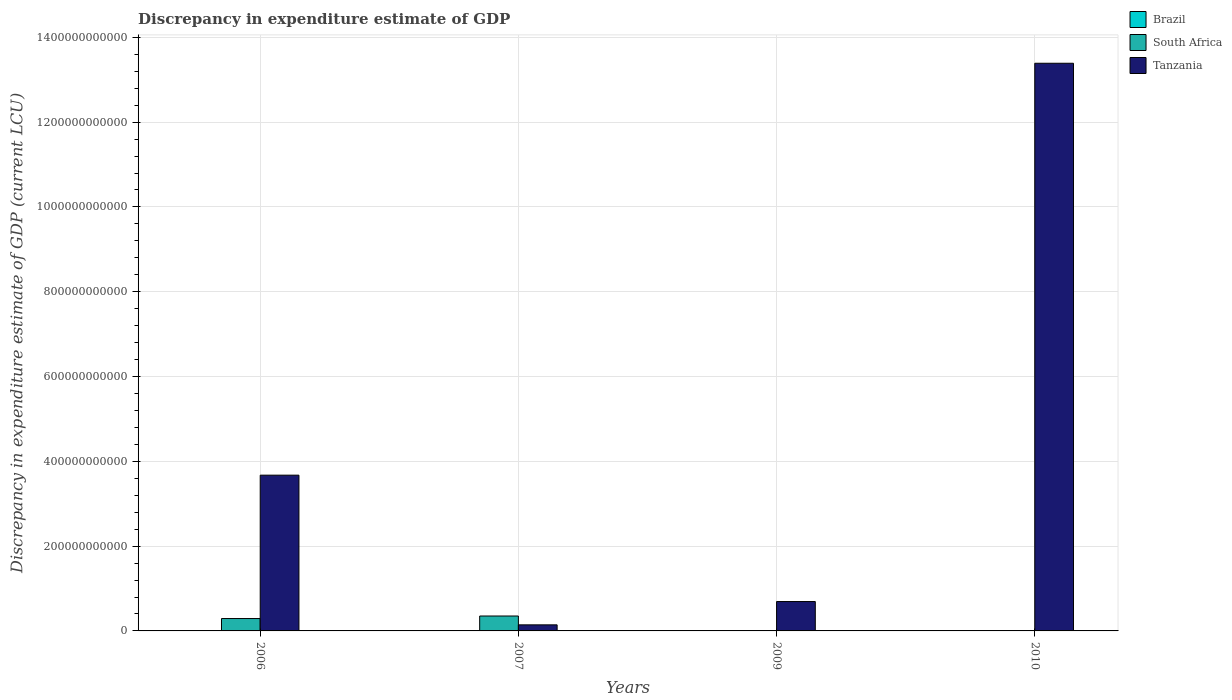Are the number of bars per tick equal to the number of legend labels?
Your response must be concise. No. In how many cases, is the number of bars for a given year not equal to the number of legend labels?
Your answer should be very brief. 4. What is the discrepancy in expenditure estimate of GDP in Brazil in 2009?
Offer a very short reply. 1.00e+06. Across all years, what is the maximum discrepancy in expenditure estimate of GDP in South Africa?
Make the answer very short. 3.52e+1. Across all years, what is the minimum discrepancy in expenditure estimate of GDP in Brazil?
Provide a short and direct response. 0. In which year was the discrepancy in expenditure estimate of GDP in South Africa maximum?
Ensure brevity in your answer.  2007. What is the total discrepancy in expenditure estimate of GDP in Tanzania in the graph?
Give a very brief answer. 1.79e+12. What is the difference between the discrepancy in expenditure estimate of GDP in Brazil in 2009 and that in 2010?
Provide a short and direct response. -0. What is the difference between the discrepancy in expenditure estimate of GDP in Tanzania in 2007 and the discrepancy in expenditure estimate of GDP in South Africa in 2010?
Keep it short and to the point. 1.43e+1. What is the average discrepancy in expenditure estimate of GDP in Brazil per year?
Make the answer very short. 5.00e+05. In the year 2006, what is the difference between the discrepancy in expenditure estimate of GDP in South Africa and discrepancy in expenditure estimate of GDP in Tanzania?
Your answer should be compact. -3.38e+11. What is the ratio of the discrepancy in expenditure estimate of GDP in Tanzania in 2006 to that in 2009?
Give a very brief answer. 5.3. What is the difference between the highest and the lowest discrepancy in expenditure estimate of GDP in South Africa?
Provide a succinct answer. 3.52e+1. Are all the bars in the graph horizontal?
Keep it short and to the point. No. What is the difference between two consecutive major ticks on the Y-axis?
Keep it short and to the point. 2.00e+11. Are the values on the major ticks of Y-axis written in scientific E-notation?
Give a very brief answer. No. Does the graph contain any zero values?
Give a very brief answer. Yes. Does the graph contain grids?
Offer a terse response. Yes. Where does the legend appear in the graph?
Offer a very short reply. Top right. How are the legend labels stacked?
Your answer should be compact. Vertical. What is the title of the graph?
Your response must be concise. Discrepancy in expenditure estimate of GDP. Does "Malaysia" appear as one of the legend labels in the graph?
Offer a terse response. No. What is the label or title of the Y-axis?
Your response must be concise. Discrepancy in expenditure estimate of GDP (current LCU). What is the Discrepancy in expenditure estimate of GDP (current LCU) in South Africa in 2006?
Give a very brief answer. 2.92e+1. What is the Discrepancy in expenditure estimate of GDP (current LCU) in Tanzania in 2006?
Give a very brief answer. 3.67e+11. What is the Discrepancy in expenditure estimate of GDP (current LCU) of Brazil in 2007?
Give a very brief answer. 0. What is the Discrepancy in expenditure estimate of GDP (current LCU) in South Africa in 2007?
Your answer should be compact. 3.52e+1. What is the Discrepancy in expenditure estimate of GDP (current LCU) of Tanzania in 2007?
Ensure brevity in your answer.  1.43e+1. What is the Discrepancy in expenditure estimate of GDP (current LCU) in Brazil in 2009?
Give a very brief answer. 1.00e+06. What is the Discrepancy in expenditure estimate of GDP (current LCU) of Tanzania in 2009?
Ensure brevity in your answer.  6.93e+1. What is the Discrepancy in expenditure estimate of GDP (current LCU) in Brazil in 2010?
Your answer should be very brief. 1.00e+06. What is the Discrepancy in expenditure estimate of GDP (current LCU) of South Africa in 2010?
Ensure brevity in your answer.  0. What is the Discrepancy in expenditure estimate of GDP (current LCU) in Tanzania in 2010?
Your response must be concise. 1.34e+12. Across all years, what is the maximum Discrepancy in expenditure estimate of GDP (current LCU) in Brazil?
Your answer should be very brief. 1.00e+06. Across all years, what is the maximum Discrepancy in expenditure estimate of GDP (current LCU) in South Africa?
Offer a very short reply. 3.52e+1. Across all years, what is the maximum Discrepancy in expenditure estimate of GDP (current LCU) of Tanzania?
Your answer should be very brief. 1.34e+12. Across all years, what is the minimum Discrepancy in expenditure estimate of GDP (current LCU) of South Africa?
Provide a succinct answer. 0. Across all years, what is the minimum Discrepancy in expenditure estimate of GDP (current LCU) in Tanzania?
Keep it short and to the point. 1.43e+1. What is the total Discrepancy in expenditure estimate of GDP (current LCU) of Brazil in the graph?
Your answer should be compact. 2.00e+06. What is the total Discrepancy in expenditure estimate of GDP (current LCU) in South Africa in the graph?
Provide a succinct answer. 6.44e+1. What is the total Discrepancy in expenditure estimate of GDP (current LCU) of Tanzania in the graph?
Your answer should be compact. 1.79e+12. What is the difference between the Discrepancy in expenditure estimate of GDP (current LCU) in South Africa in 2006 and that in 2007?
Keep it short and to the point. -5.99e+09. What is the difference between the Discrepancy in expenditure estimate of GDP (current LCU) of Tanzania in 2006 and that in 2007?
Offer a terse response. 3.53e+11. What is the difference between the Discrepancy in expenditure estimate of GDP (current LCU) of Tanzania in 2006 and that in 2009?
Provide a short and direct response. 2.98e+11. What is the difference between the Discrepancy in expenditure estimate of GDP (current LCU) in Tanzania in 2006 and that in 2010?
Offer a very short reply. -9.72e+11. What is the difference between the Discrepancy in expenditure estimate of GDP (current LCU) in Tanzania in 2007 and that in 2009?
Offer a very short reply. -5.50e+1. What is the difference between the Discrepancy in expenditure estimate of GDP (current LCU) in Tanzania in 2007 and that in 2010?
Your answer should be very brief. -1.32e+12. What is the difference between the Discrepancy in expenditure estimate of GDP (current LCU) of Brazil in 2009 and that in 2010?
Your answer should be very brief. -0. What is the difference between the Discrepancy in expenditure estimate of GDP (current LCU) in Tanzania in 2009 and that in 2010?
Give a very brief answer. -1.27e+12. What is the difference between the Discrepancy in expenditure estimate of GDP (current LCU) of South Africa in 2006 and the Discrepancy in expenditure estimate of GDP (current LCU) of Tanzania in 2007?
Offer a terse response. 1.49e+1. What is the difference between the Discrepancy in expenditure estimate of GDP (current LCU) of South Africa in 2006 and the Discrepancy in expenditure estimate of GDP (current LCU) of Tanzania in 2009?
Make the answer very short. -4.01e+1. What is the difference between the Discrepancy in expenditure estimate of GDP (current LCU) in South Africa in 2006 and the Discrepancy in expenditure estimate of GDP (current LCU) in Tanzania in 2010?
Your response must be concise. -1.31e+12. What is the difference between the Discrepancy in expenditure estimate of GDP (current LCU) in South Africa in 2007 and the Discrepancy in expenditure estimate of GDP (current LCU) in Tanzania in 2009?
Offer a very short reply. -3.41e+1. What is the difference between the Discrepancy in expenditure estimate of GDP (current LCU) of South Africa in 2007 and the Discrepancy in expenditure estimate of GDP (current LCU) of Tanzania in 2010?
Ensure brevity in your answer.  -1.30e+12. What is the difference between the Discrepancy in expenditure estimate of GDP (current LCU) in Brazil in 2009 and the Discrepancy in expenditure estimate of GDP (current LCU) in Tanzania in 2010?
Offer a very short reply. -1.34e+12. What is the average Discrepancy in expenditure estimate of GDP (current LCU) of Brazil per year?
Provide a short and direct response. 5.00e+05. What is the average Discrepancy in expenditure estimate of GDP (current LCU) in South Africa per year?
Your answer should be compact. 1.61e+1. What is the average Discrepancy in expenditure estimate of GDP (current LCU) of Tanzania per year?
Provide a short and direct response. 4.47e+11. In the year 2006, what is the difference between the Discrepancy in expenditure estimate of GDP (current LCU) of South Africa and Discrepancy in expenditure estimate of GDP (current LCU) of Tanzania?
Provide a succinct answer. -3.38e+11. In the year 2007, what is the difference between the Discrepancy in expenditure estimate of GDP (current LCU) in South Africa and Discrepancy in expenditure estimate of GDP (current LCU) in Tanzania?
Give a very brief answer. 2.09e+1. In the year 2009, what is the difference between the Discrepancy in expenditure estimate of GDP (current LCU) of Brazil and Discrepancy in expenditure estimate of GDP (current LCU) of Tanzania?
Provide a short and direct response. -6.93e+1. In the year 2010, what is the difference between the Discrepancy in expenditure estimate of GDP (current LCU) in Brazil and Discrepancy in expenditure estimate of GDP (current LCU) in Tanzania?
Your response must be concise. -1.34e+12. What is the ratio of the Discrepancy in expenditure estimate of GDP (current LCU) of South Africa in 2006 to that in 2007?
Offer a very short reply. 0.83. What is the ratio of the Discrepancy in expenditure estimate of GDP (current LCU) in Tanzania in 2006 to that in 2007?
Offer a terse response. 25.66. What is the ratio of the Discrepancy in expenditure estimate of GDP (current LCU) in Tanzania in 2006 to that in 2009?
Give a very brief answer. 5.3. What is the ratio of the Discrepancy in expenditure estimate of GDP (current LCU) of Tanzania in 2006 to that in 2010?
Provide a short and direct response. 0.27. What is the ratio of the Discrepancy in expenditure estimate of GDP (current LCU) in Tanzania in 2007 to that in 2009?
Offer a terse response. 0.21. What is the ratio of the Discrepancy in expenditure estimate of GDP (current LCU) of Tanzania in 2007 to that in 2010?
Your answer should be very brief. 0.01. What is the ratio of the Discrepancy in expenditure estimate of GDP (current LCU) of Brazil in 2009 to that in 2010?
Offer a very short reply. 1. What is the ratio of the Discrepancy in expenditure estimate of GDP (current LCU) in Tanzania in 2009 to that in 2010?
Give a very brief answer. 0.05. What is the difference between the highest and the second highest Discrepancy in expenditure estimate of GDP (current LCU) of Tanzania?
Provide a succinct answer. 9.72e+11. What is the difference between the highest and the lowest Discrepancy in expenditure estimate of GDP (current LCU) in Brazil?
Provide a short and direct response. 1.00e+06. What is the difference between the highest and the lowest Discrepancy in expenditure estimate of GDP (current LCU) in South Africa?
Your response must be concise. 3.52e+1. What is the difference between the highest and the lowest Discrepancy in expenditure estimate of GDP (current LCU) of Tanzania?
Your response must be concise. 1.32e+12. 